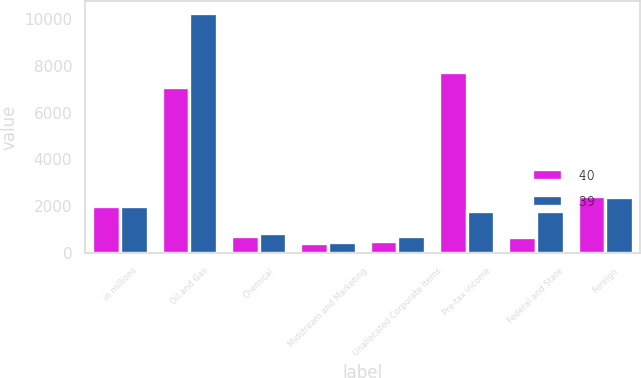Convert chart to OTSL. <chart><loc_0><loc_0><loc_500><loc_500><stacked_bar_chart><ecel><fcel>in millions<fcel>Oil and Gas<fcel>Chemical<fcel>Midstream and Marketing<fcel>Unallocated Corporate Items<fcel>Pre-tax income<fcel>Federal and State<fcel>Foreign<nl><fcel>40<fcel>2012<fcel>7095<fcel>720<fcel>439<fcel>501<fcel>7753<fcel>694<fcel>2424<nl><fcel>39<fcel>2011<fcel>10241<fcel>861<fcel>448<fcel>709<fcel>1795<fcel>1795<fcel>2406<nl></chart> 